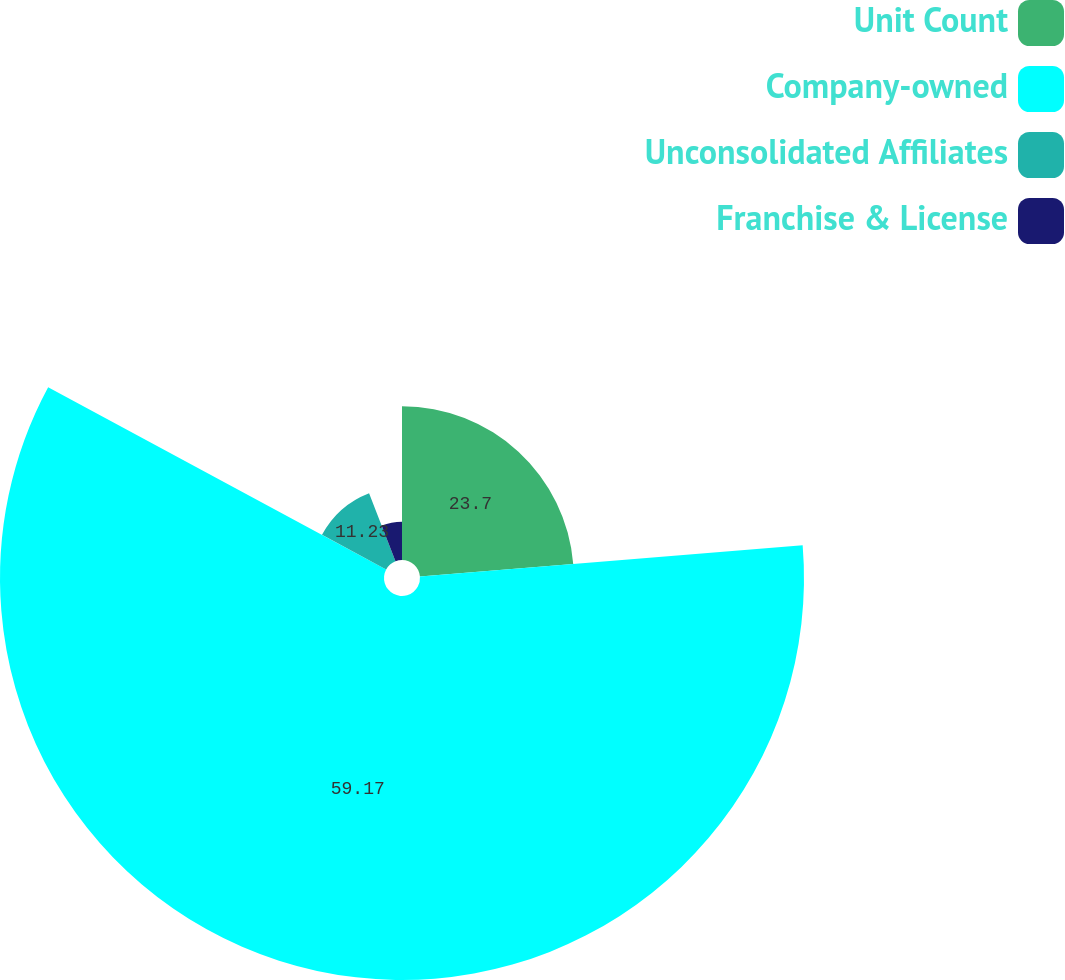<chart> <loc_0><loc_0><loc_500><loc_500><pie_chart><fcel>Unit Count<fcel>Company-owned<fcel>Unconsolidated Affiliates<fcel>Franchise & License<nl><fcel>23.7%<fcel>59.17%<fcel>11.23%<fcel>5.9%<nl></chart> 